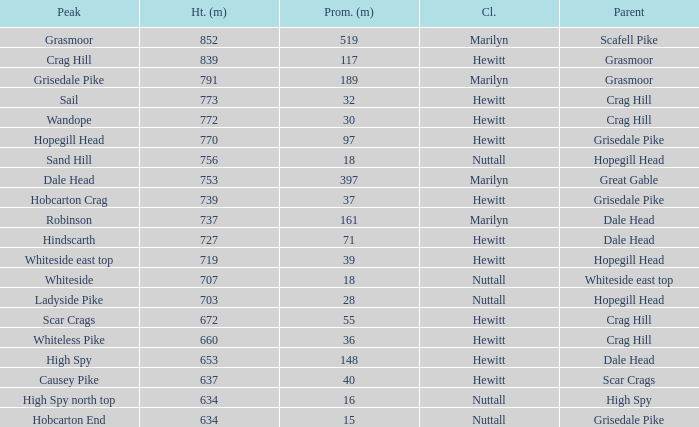What is the lowest height for Parent grasmoor when it has a Prom larger than 117? 791.0. 